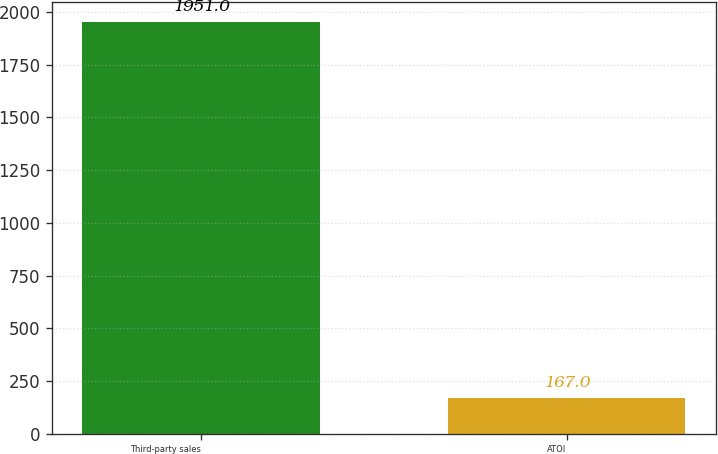<chart> <loc_0><loc_0><loc_500><loc_500><bar_chart><fcel>Third-party sales<fcel>ATOI<nl><fcel>1951<fcel>167<nl></chart> 